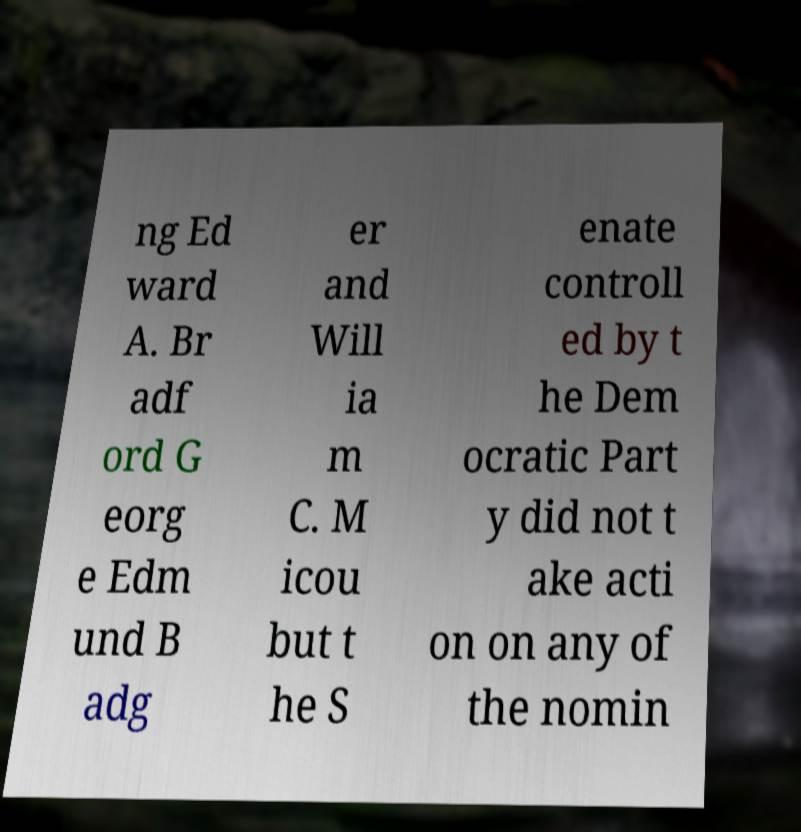Can you accurately transcribe the text from the provided image for me? ng Ed ward A. Br adf ord G eorg e Edm und B adg er and Will ia m C. M icou but t he S enate controll ed by t he Dem ocratic Part y did not t ake acti on on any of the nomin 